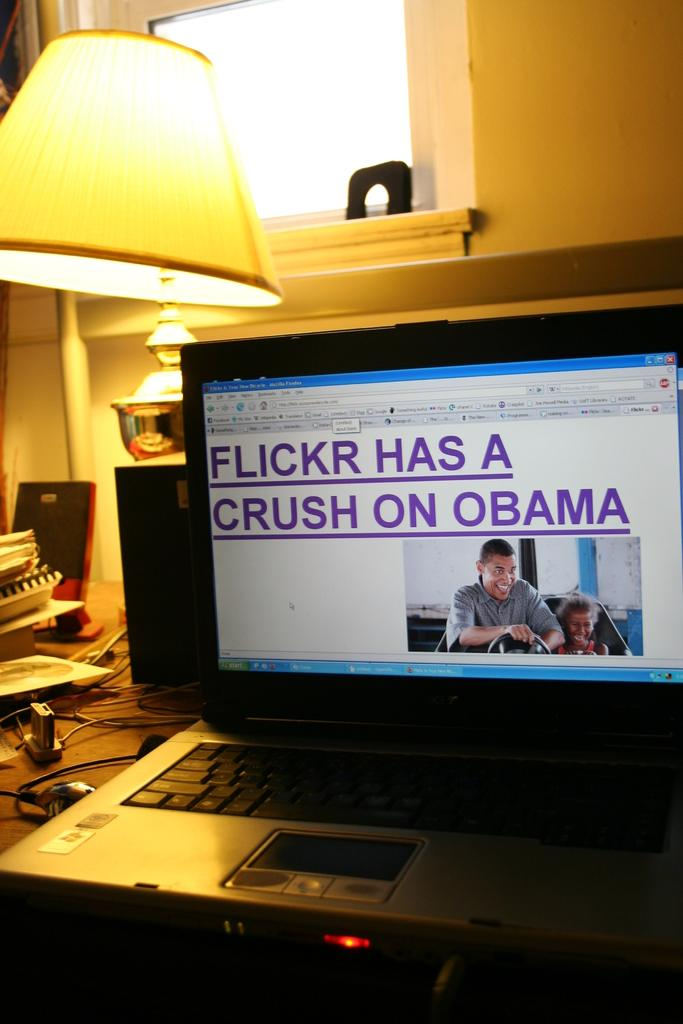What is the main object in the middle of the image? There is a laptop in the middle of the image. What can be seen on the left side of the image? There is a lamp on the left side of the image. What type of reward is the minister holding in the image? There is no minister or reward present in the image. Is there any sand visible in the image? No, there is no sand visible in the image. 